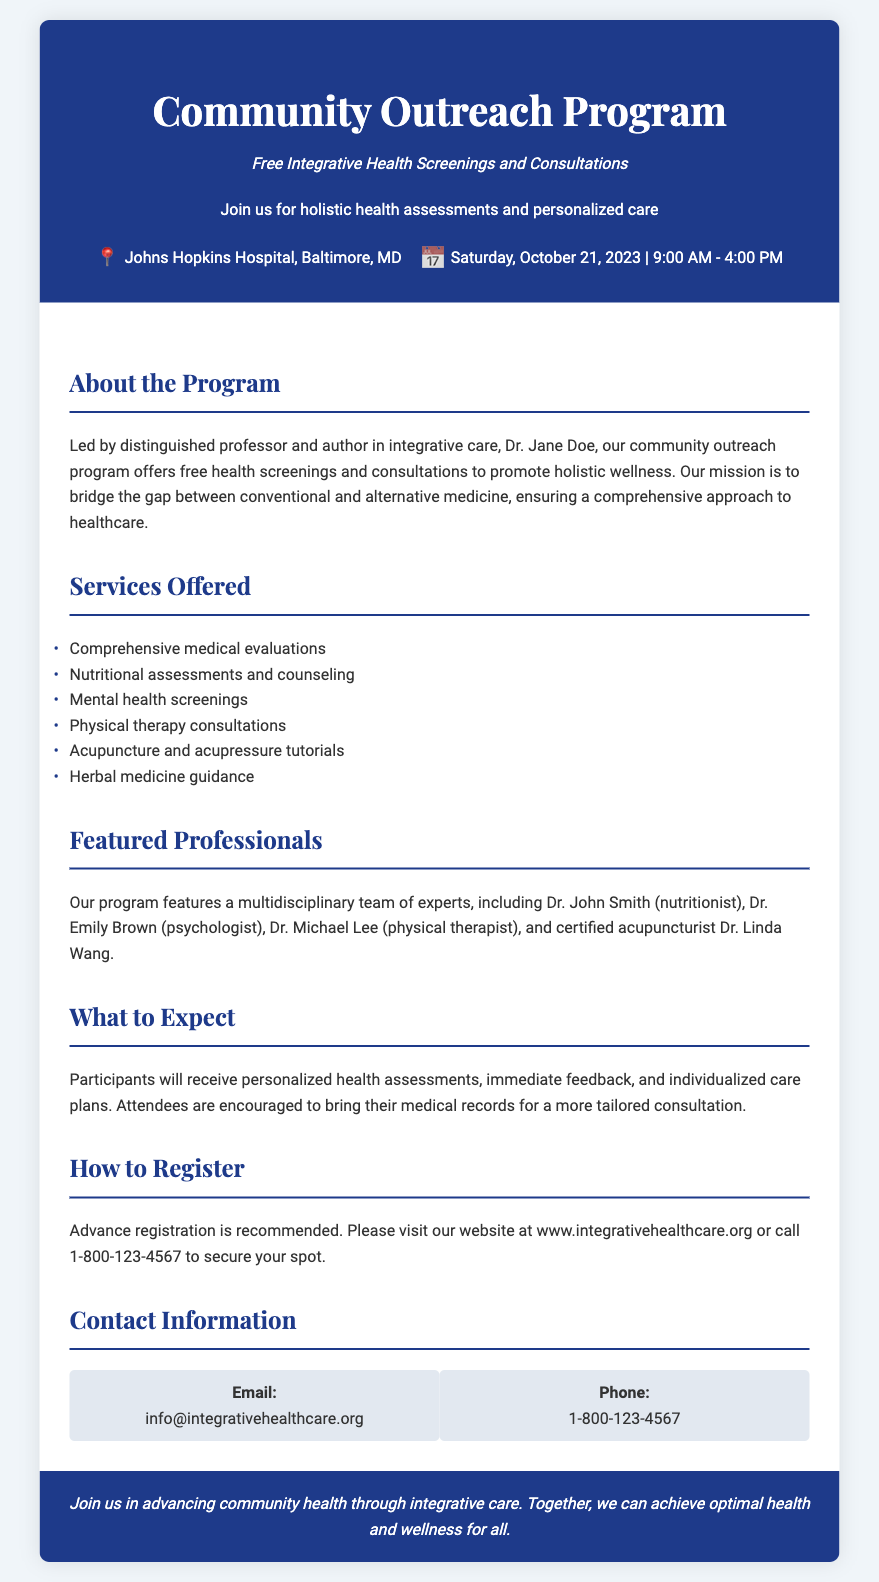What is the event date? The event is scheduled to take place on Saturday, October 21, 2023.
Answer: Saturday, October 21, 2023 Where is the event located? The location of the event is mentioned as Johns Hopkins Hospital, Baltimore, MD.
Answer: Johns Hopkins Hospital, Baltimore, MD Who is leading the program? The document specifies that Dr. Jane Doe, a distinguished professor and author, is leading the program.
Answer: Dr. Jane Doe What services are offered? The document lists various services, including nutritional assessments and counseling, among others.
Answer: Nutritional assessments and counseling How can one register for the program? The registration method involves visiting the website or calling a specific phone number for more information.
Answer: Visit our website at www.integrativehealthcare.org or call 1-800-123-4567 Name one of the featured professionals. The document mentions several professionals, including Dr. John Smith, who is a nutritionist.
Answer: Dr. John Smith What type of health assessments will participants receive? Participants will receive personalized health assessments as part of the consultations offered.
Answer: Personalized health assessments What should attendees bring for their consultations? The document suggests that attendees are encouraged to bring their medical records for tailored consultations.
Answer: Medical records 